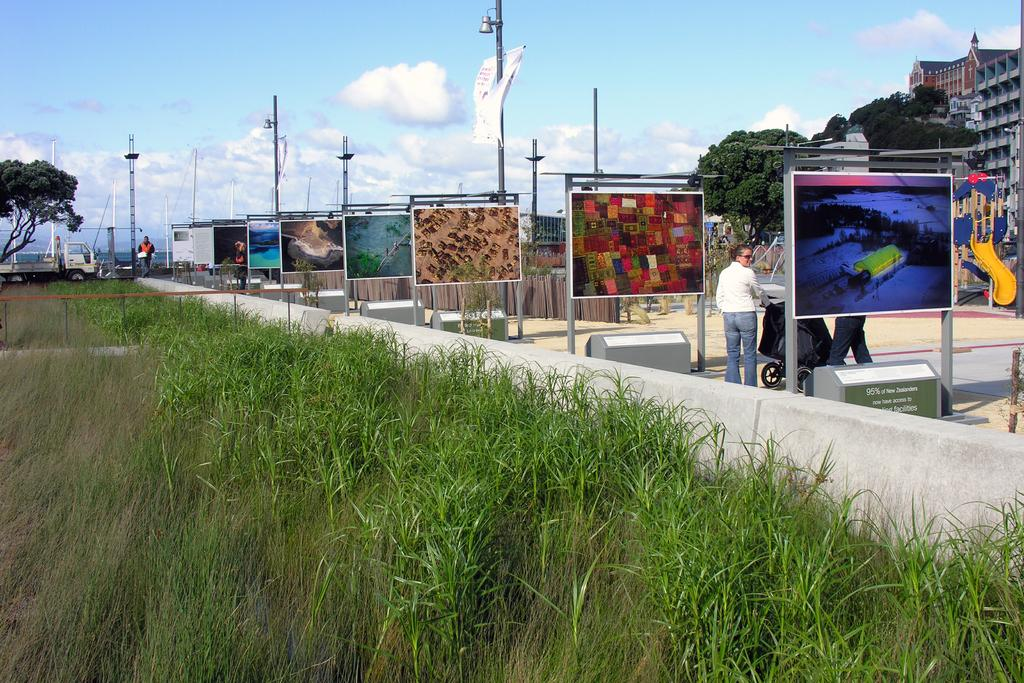What type of natural environment is present in the image? The image contains grass and trees. What can be seen on the right side of the image? There are paintings on boards on the right side of the image. Who is present in the image? A woman is standing in the image. What type of structures are visible in the image? There are buildings in the image. What is visible at the top of the image? The sky is visible at the top of the image. What type of cart is being used to transport the desk in the image? There is no cart or desk present in the image. 